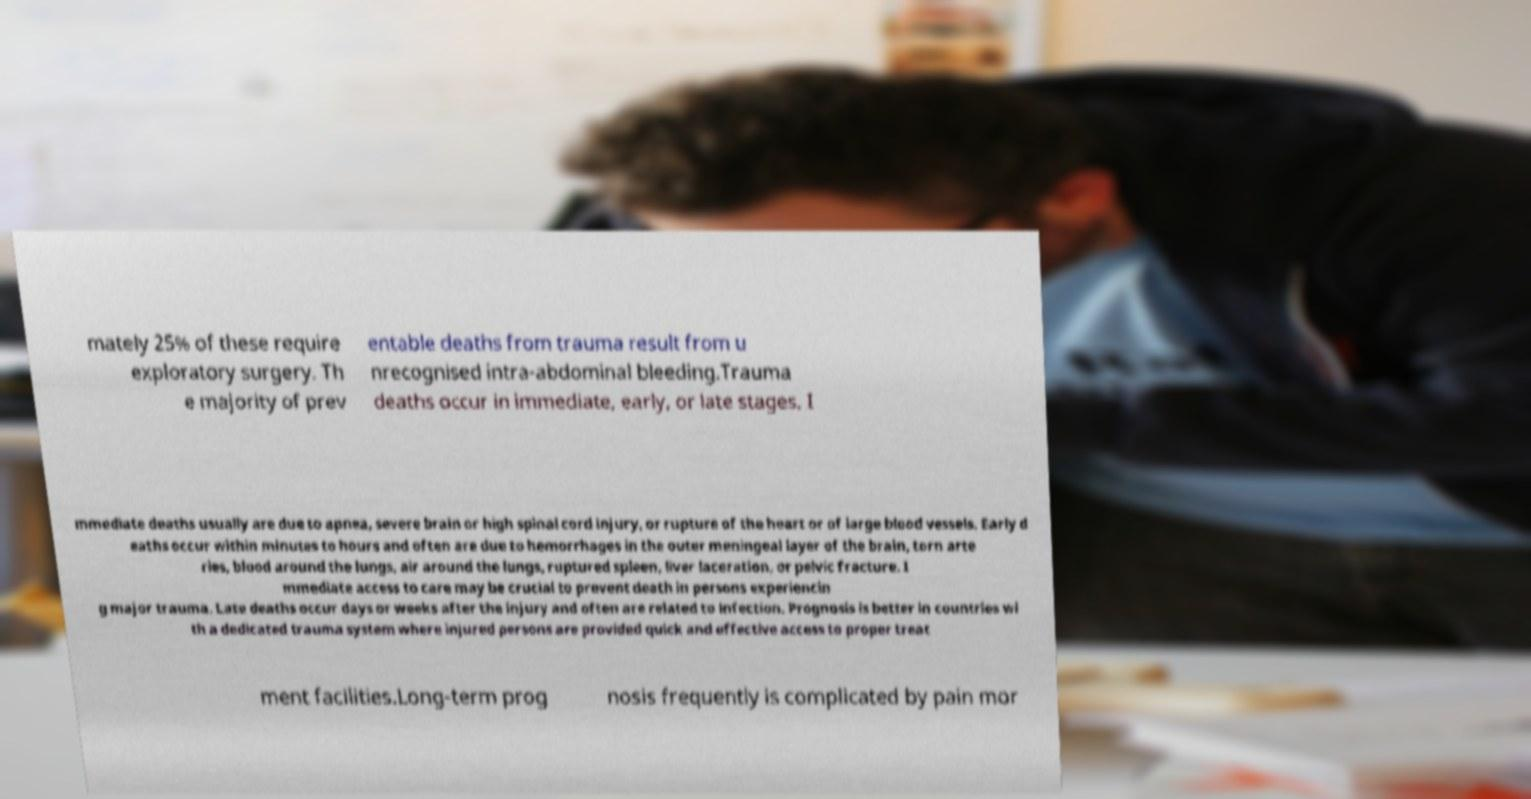There's text embedded in this image that I need extracted. Can you transcribe it verbatim? mately 25% of these require exploratory surgery. Th e majority of prev entable deaths from trauma result from u nrecognised intra-abdominal bleeding.Trauma deaths occur in immediate, early, or late stages. I mmediate deaths usually are due to apnea, severe brain or high spinal cord injury, or rupture of the heart or of large blood vessels. Early d eaths occur within minutes to hours and often are due to hemorrhages in the outer meningeal layer of the brain, torn arte ries, blood around the lungs, air around the lungs, ruptured spleen, liver laceration, or pelvic fracture. I mmediate access to care may be crucial to prevent death in persons experiencin g major trauma. Late deaths occur days or weeks after the injury and often are related to infection. Prognosis is better in countries wi th a dedicated trauma system where injured persons are provided quick and effective access to proper treat ment facilities.Long-term prog nosis frequently is complicated by pain mor 